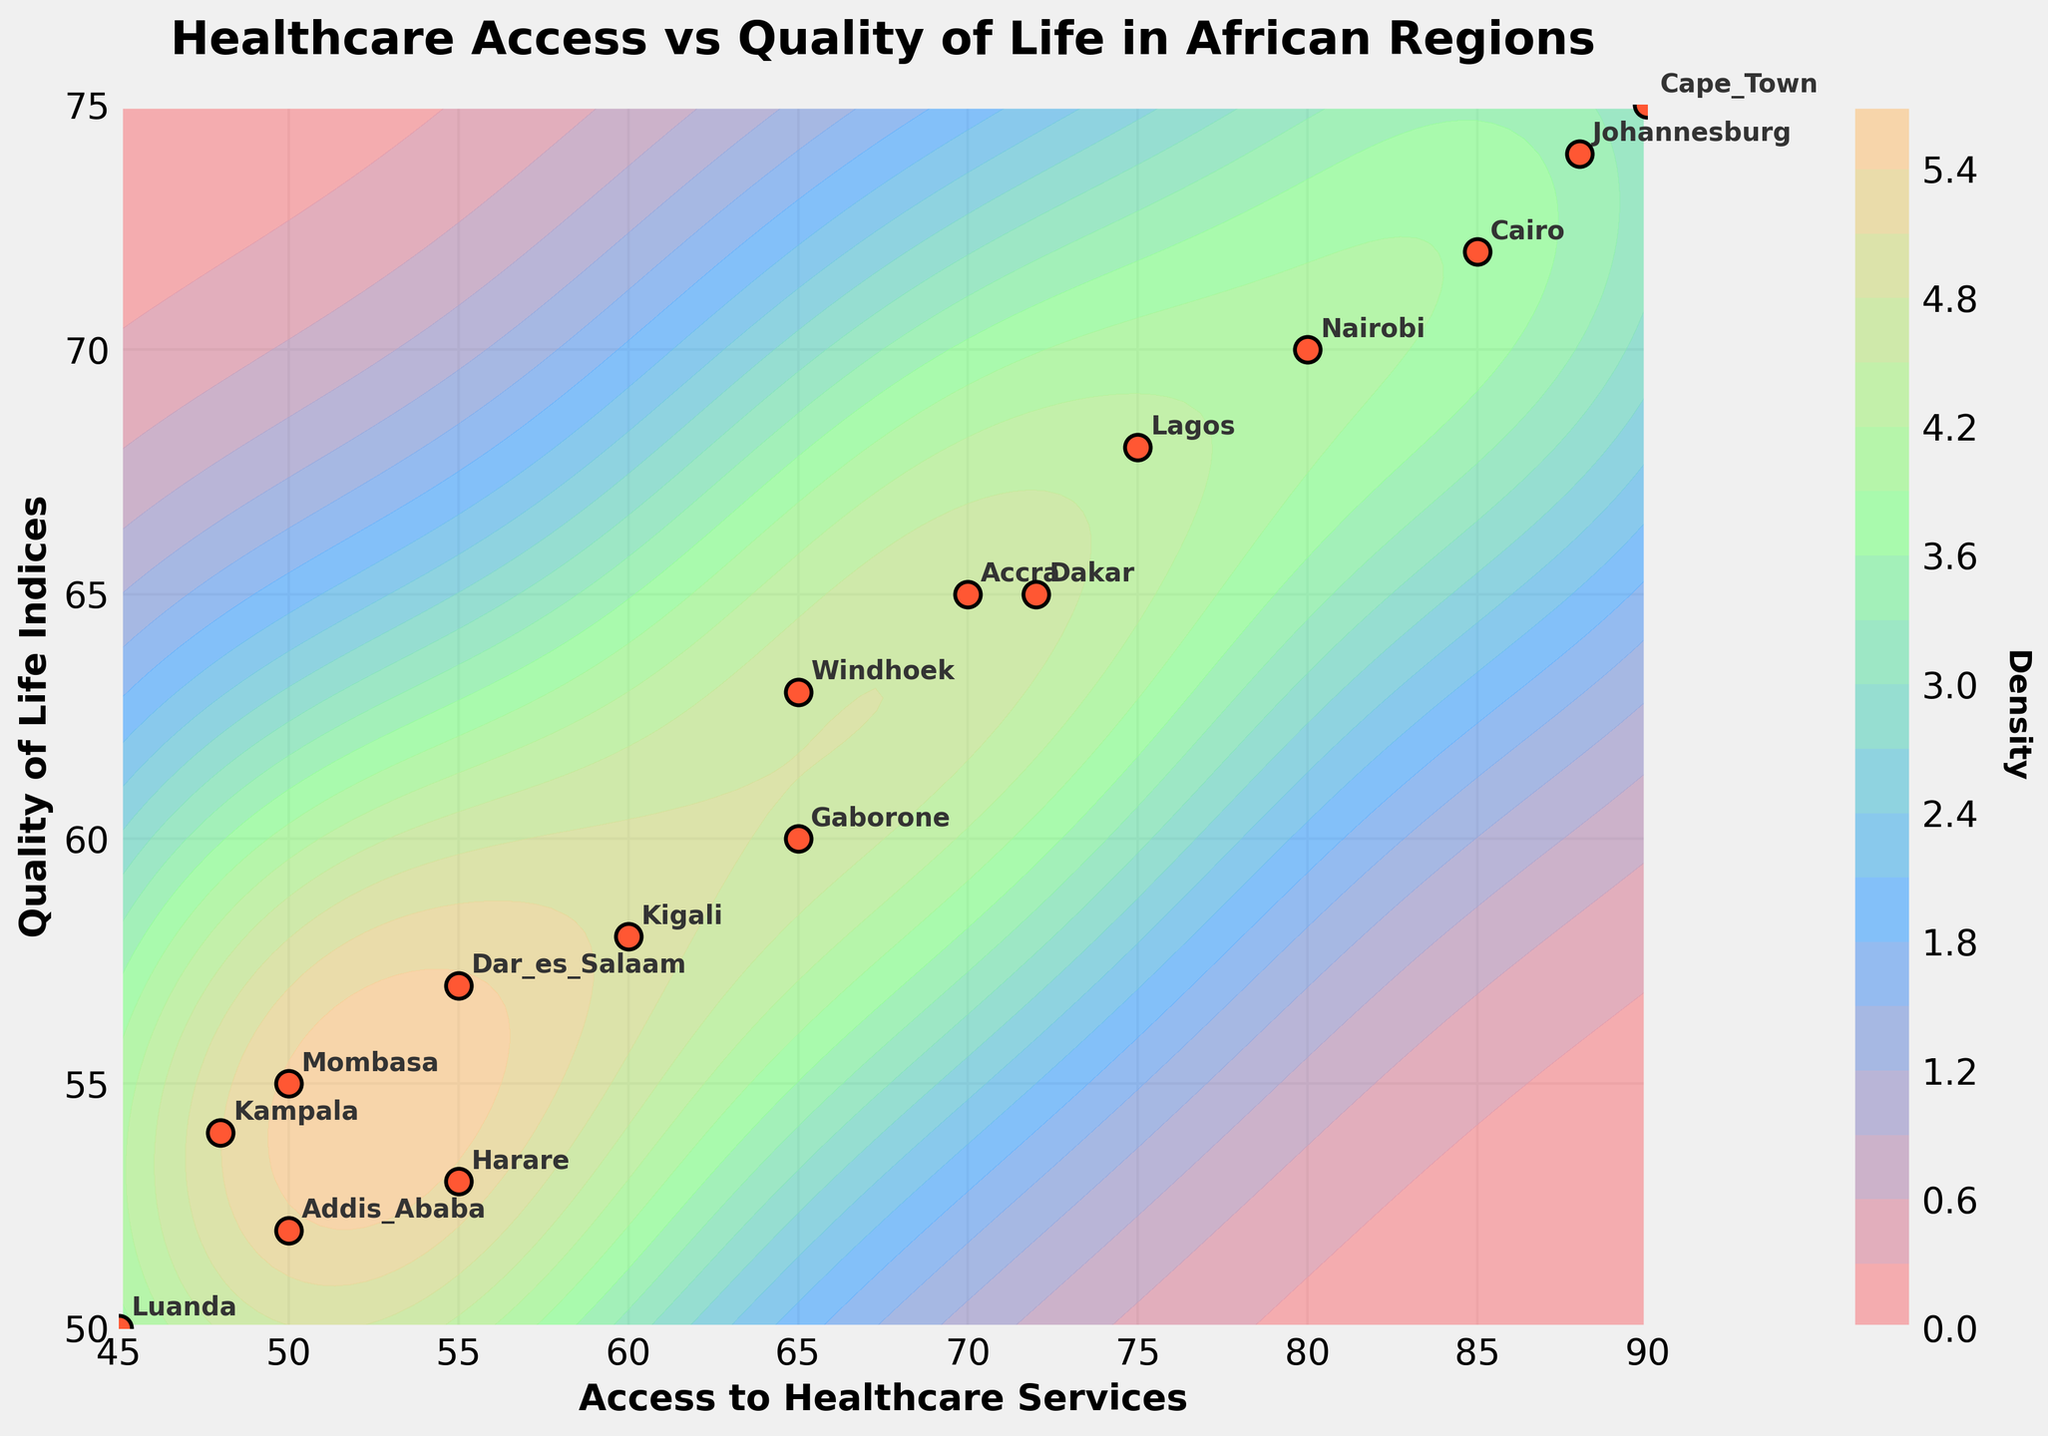what's the title of the plot? The title of the plot is written at the top in bold font. The title is "Healthcare Access vs Quality of Life in African Regions".
Answer: Healthcare Access vs Quality of Life in African Regions what are the axes labels? The labels for each axis are provided beside the respective axes. The x-axis is labeled "Access to Healthcare Services" and the y-axis is labeled "Quality of Life Indices".
Answer: Access to Healthcare Services (x-axis), Quality of Life Indices (y-axis) which region has the highest access to healthcare services? By looking at the farthest point along the x-axis, the region with the highest value is noted. Cape Town has the highest access to healthcare services, with a value of 90.
Answer: Cape Town how many regions have a quality of life index greater than 70? Count the data points that are located above the y=70 line. Nairobi, Cairo, Cape Town, and Johannesburg have quality of life indices greater than 70.
Answer: 4 which region has the lowest quality of life index and what is its value? Locate the point farthest down the y-axis. Luanda has the lowest quality of life index, with a value of 50.
Answer: Luanda, 50 what's the average access to healthcare services among the regions? Sum the access to healthcare services values and divide by the number of regions (75 + 80 + 70 + 85 + 90 + 65 + 50 + 60 + 88 + 50 + 72 + 55 + 45 + 65 + 48 + 55). The sum is 1118 and there are 16 regions, so 1118 / 16.
Answer: 69.875 how does Kigali compare to Mombasa in terms of quality of life indices? Compare the y-values of Kigali and Mombasa. Kigali has a value of 58 and Mombasa has 55.
Answer: Kigali is higher which two regions are closest together in terms of both healthcare access and quality of life indices? Examine the Euclidean distances between all pairs and identify the smallest distance. Addis Ababa and Kampala are closest to each other.
Answer: Addis Ababa and Kampala is there a general trend between access to healthcare services and quality of life indices? By observing the overall distribution of the points and contour lines, there's an apparent positive trend, though not perfectly linear. Regions with higher access to healthcare often have higher quality of life indices.
Answer: Positive trend which region is an outlier having very high access to healthcare but relatively low quality of life index? Identify any point with a high x-value but comparatively low y-value. Nairobi stands out with an access of 80 and quality of life indices of 70, being less than expected relative to other similar access points.
Answer: Nairobi 